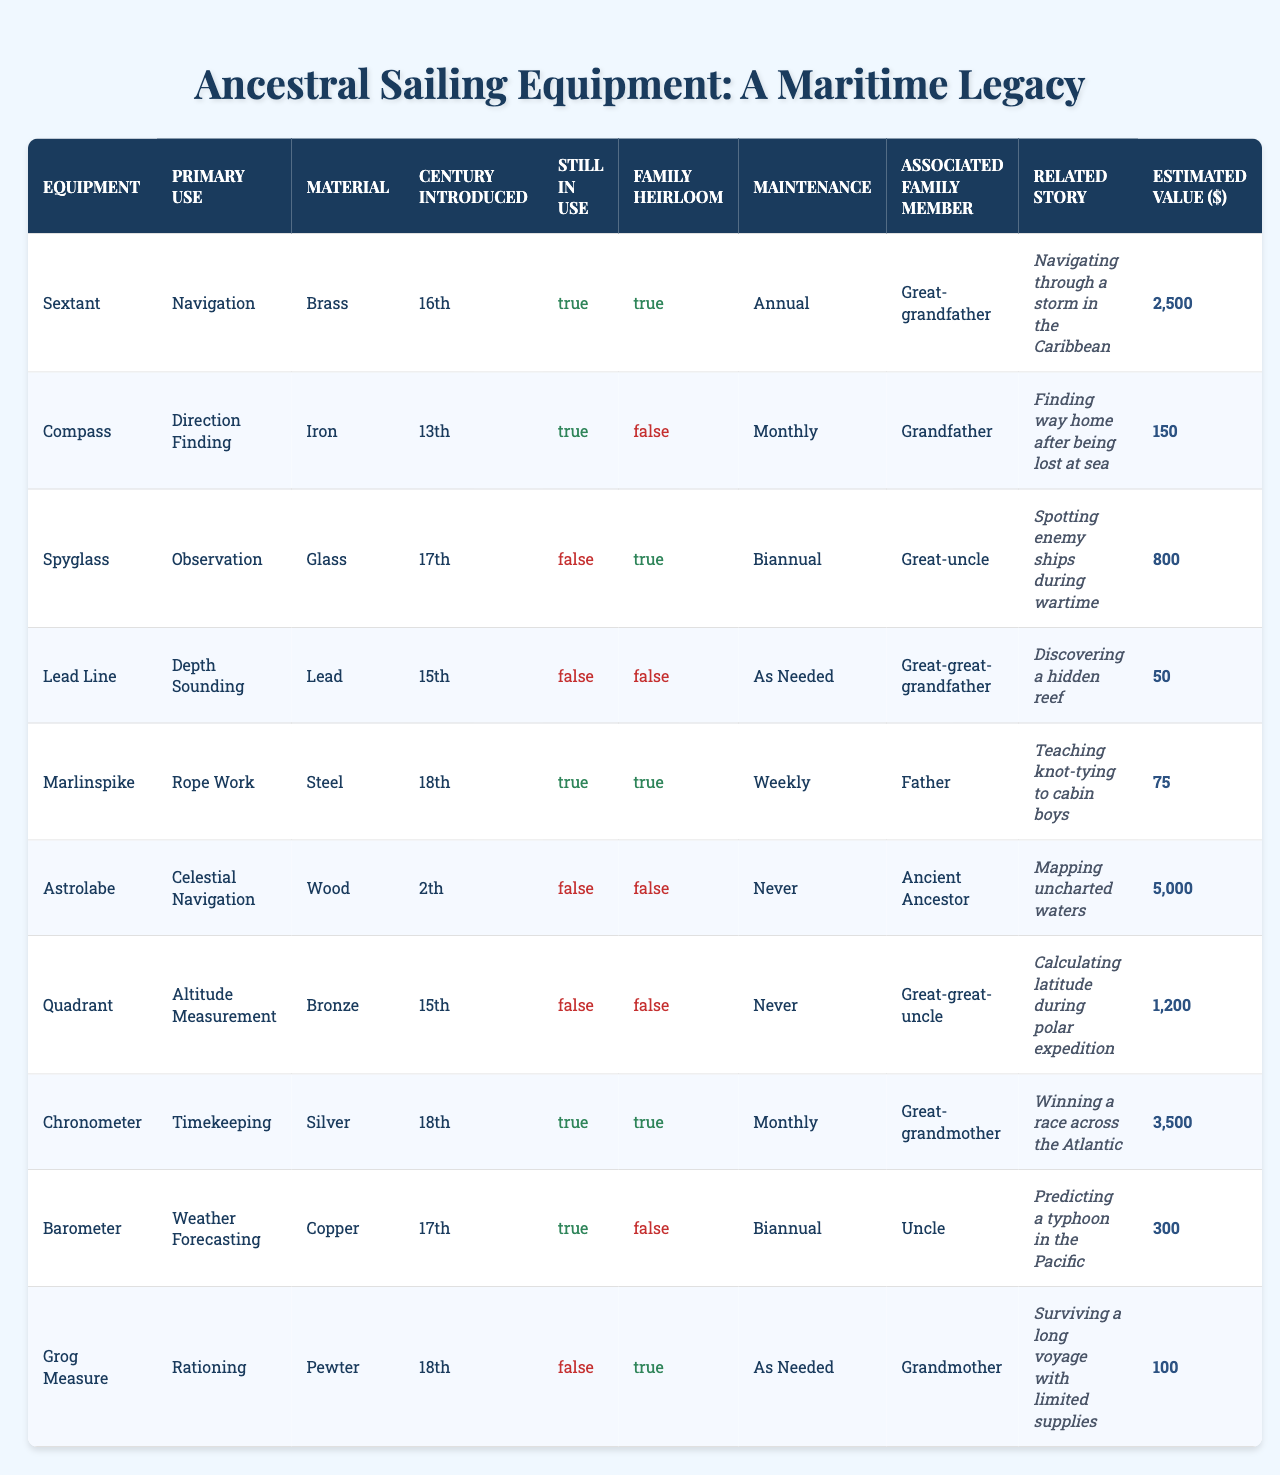What is the primary use of the sextant? The sextant is listed under the "Primary Use" column in the table, where it shows "Navigation."
Answer: Navigation Which equipment is made of wood? In the "Material" column, we look for the entry that lists "Wood," which corresponds to "Marlinspike."
Answer: Marlinspike How many pieces of equipment are still in use? By counting the entries in the "Still in Use" column that are marked as true, we find there are 5 pieces of equipment still in use.
Answer: 5 Is the compass a family heirloom? We check the "Family Heirloom" column for "Compass," which is marked as false.
Answer: No What is the estimated value of the chronometer? The estimated value for "Chronometer" in the "Estimated Value ($)" column is listed as 3,500.
Answer: 3,500 Which equipment has the oldest introduction century? The "Astrolabe" was introduced in the 2nd century, which is the earliest in the "Century Introduced" column.
Answer: Astrolabe How many pieces of equipment are made from metal? The metals listed are brass, iron, lead, steel, bronze, silver, and copper. Counting the unique metals yields 7 items (Sextant, Compass, Spyglass, Marlinspike, Chronometer, Barometer, Grog Measure).
Answer: 7 Which family member is associated with the lead line? By referring to the "Associated Family Member" column, we see that the "Lead Line" corresponds to "Great-great-grandfather."
Answer: Great-great-grandfather What is the difference in estimated values between the most valuable and least valuable equipment? The most valuable equipment is the "Astrolabe" at 5,000, and the least is the "Lead Line" at 50. The difference is 5,000 - 50 = 4,950.
Answer: 4,950 How many tools require annual maintenance? From the "Maintenance Frequency" column, only the "Sextant" requires annual maintenance, so there is 1 tool.
Answer: 1 